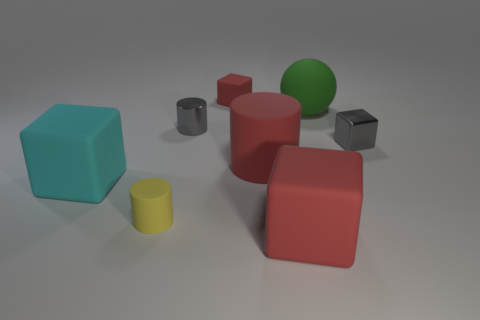Subtract all large cyan matte cubes. How many cubes are left? 3 Subtract all gray spheres. How many red cubes are left? 2 Subtract 3 blocks. How many blocks are left? 1 Add 1 shiny objects. How many objects exist? 9 Subtract all red cubes. How many cubes are left? 2 Subtract all cyan cylinders. Subtract all purple cubes. How many cylinders are left? 3 Add 6 red objects. How many red objects exist? 9 Subtract 0 blue spheres. How many objects are left? 8 Subtract all cylinders. How many objects are left? 5 Subtract all gray cylinders. Subtract all gray shiny cylinders. How many objects are left? 6 